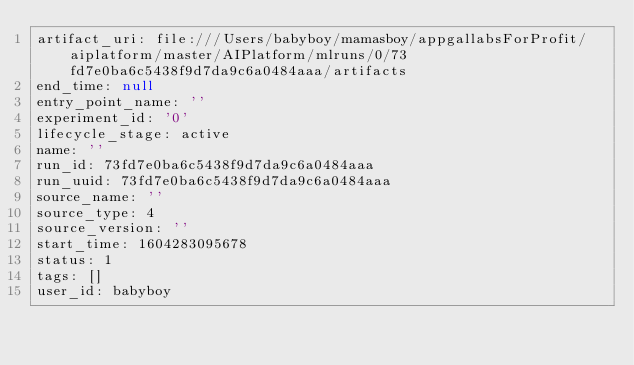<code> <loc_0><loc_0><loc_500><loc_500><_YAML_>artifact_uri: file:///Users/babyboy/mamasboy/appgallabsForProfit/aiplatform/master/AIPlatform/mlruns/0/73fd7e0ba6c5438f9d7da9c6a0484aaa/artifacts
end_time: null
entry_point_name: ''
experiment_id: '0'
lifecycle_stage: active
name: ''
run_id: 73fd7e0ba6c5438f9d7da9c6a0484aaa
run_uuid: 73fd7e0ba6c5438f9d7da9c6a0484aaa
source_name: ''
source_type: 4
source_version: ''
start_time: 1604283095678
status: 1
tags: []
user_id: babyboy
</code> 